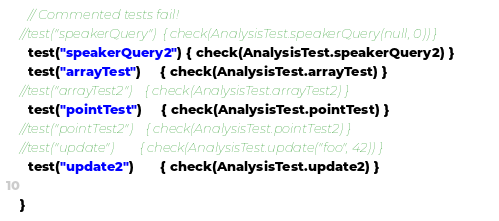<code> <loc_0><loc_0><loc_500><loc_500><_Scala_>  // Commented tests fail!
//test("speakerQuery")  { check(AnalysisTest.speakerQuery(null, 0)) }
  test("speakerQuery2") { check(AnalysisTest.speakerQuery2) }
  test("arrayTest")     { check(AnalysisTest.arrayTest) }
//test("arrayTest2")    { check(AnalysisTest.arrayTest2) }
  test("pointTest")     { check(AnalysisTest.pointTest) }
//test("pointTest2")    { check(AnalysisTest.pointTest2) }
//test("update")        { check(AnalysisTest.update("foo", 42)) }
  test("update2")       { check(AnalysisTest.update2) }

}
</code> 